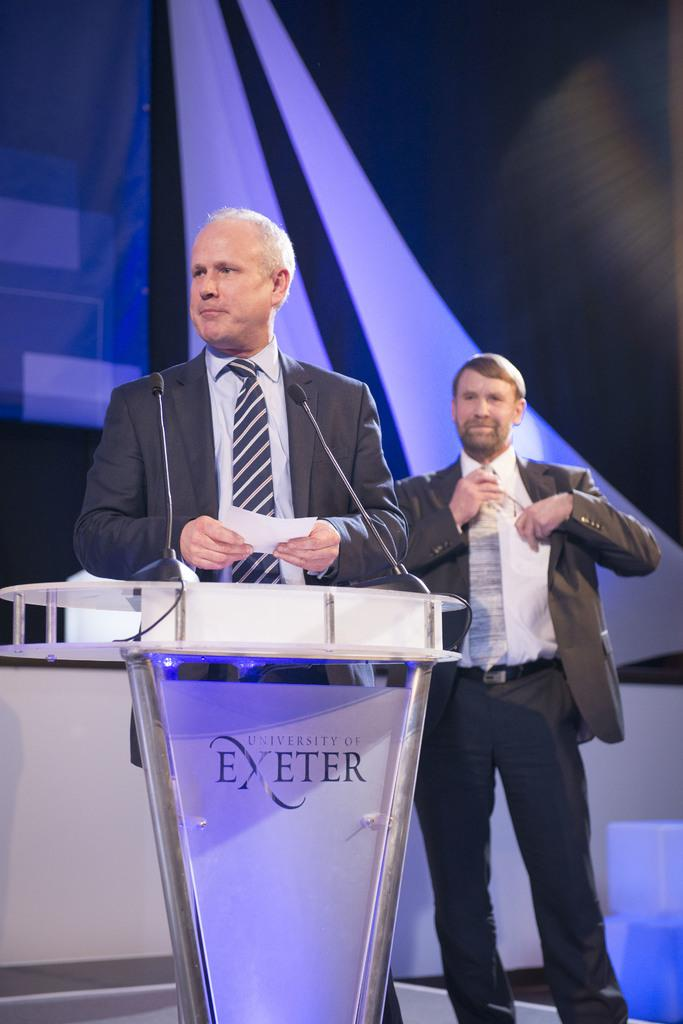Provide a one-sentence caption for the provided image. A man gives a speech at the University of Exeter. 